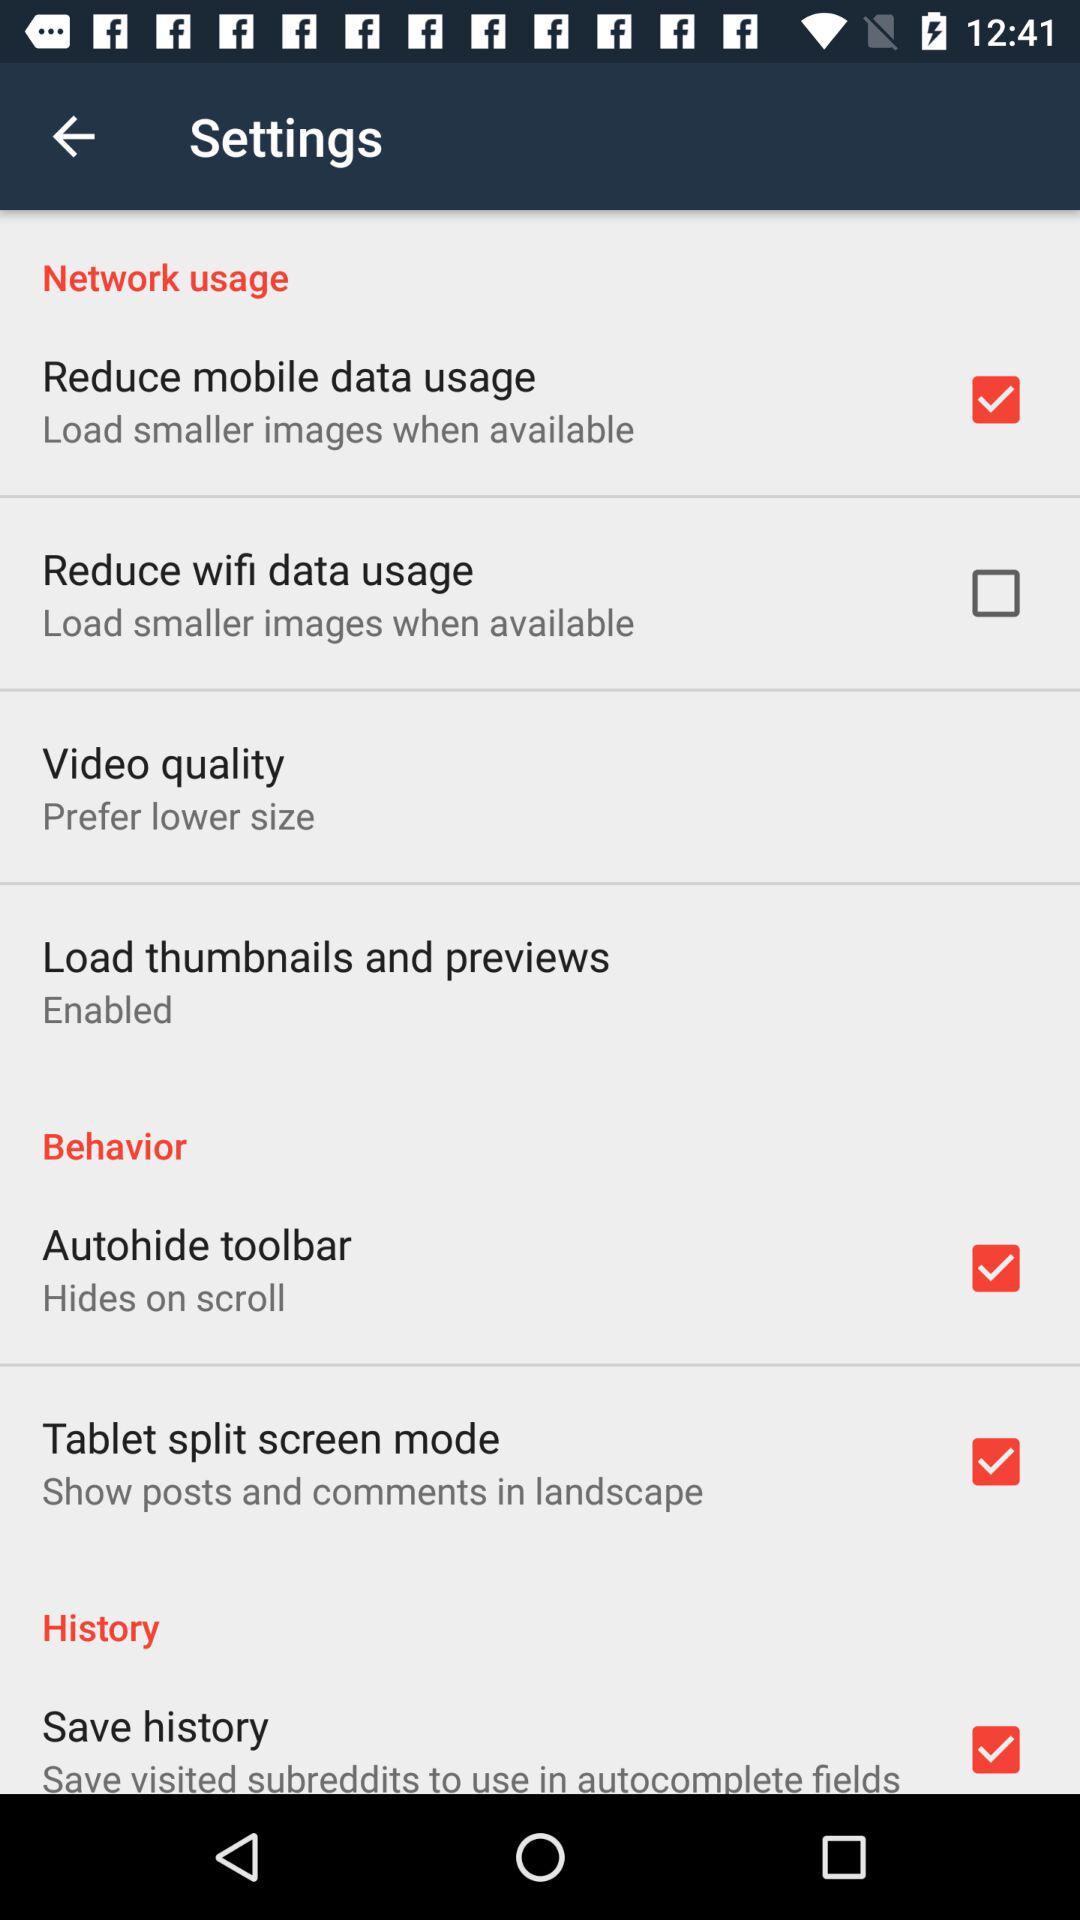Which "Network usage" is selected? The selected network usage is "Reduce mobile data usage". 